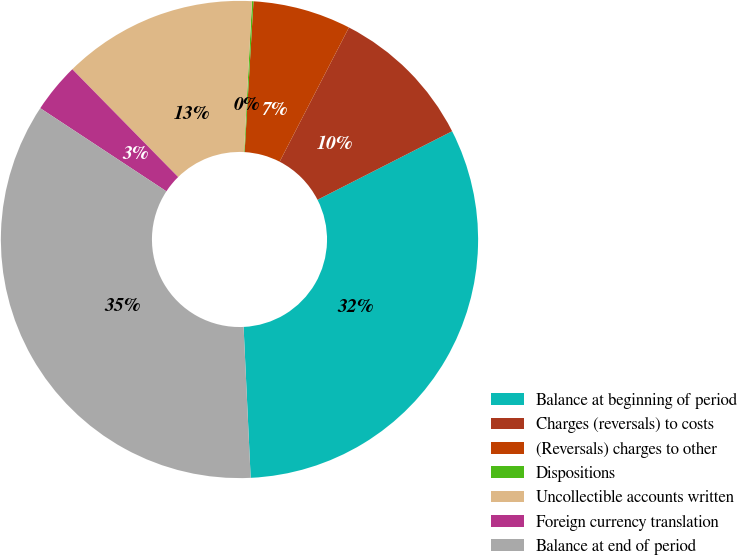<chart> <loc_0><loc_0><loc_500><loc_500><pie_chart><fcel>Balance at beginning of period<fcel>Charges (reversals) to costs<fcel>(Reversals) charges to other<fcel>Dispositions<fcel>Uncollectible accounts written<fcel>Foreign currency translation<fcel>Balance at end of period<nl><fcel>31.75%<fcel>9.92%<fcel>6.65%<fcel>0.1%<fcel>13.19%<fcel>3.37%<fcel>35.02%<nl></chart> 